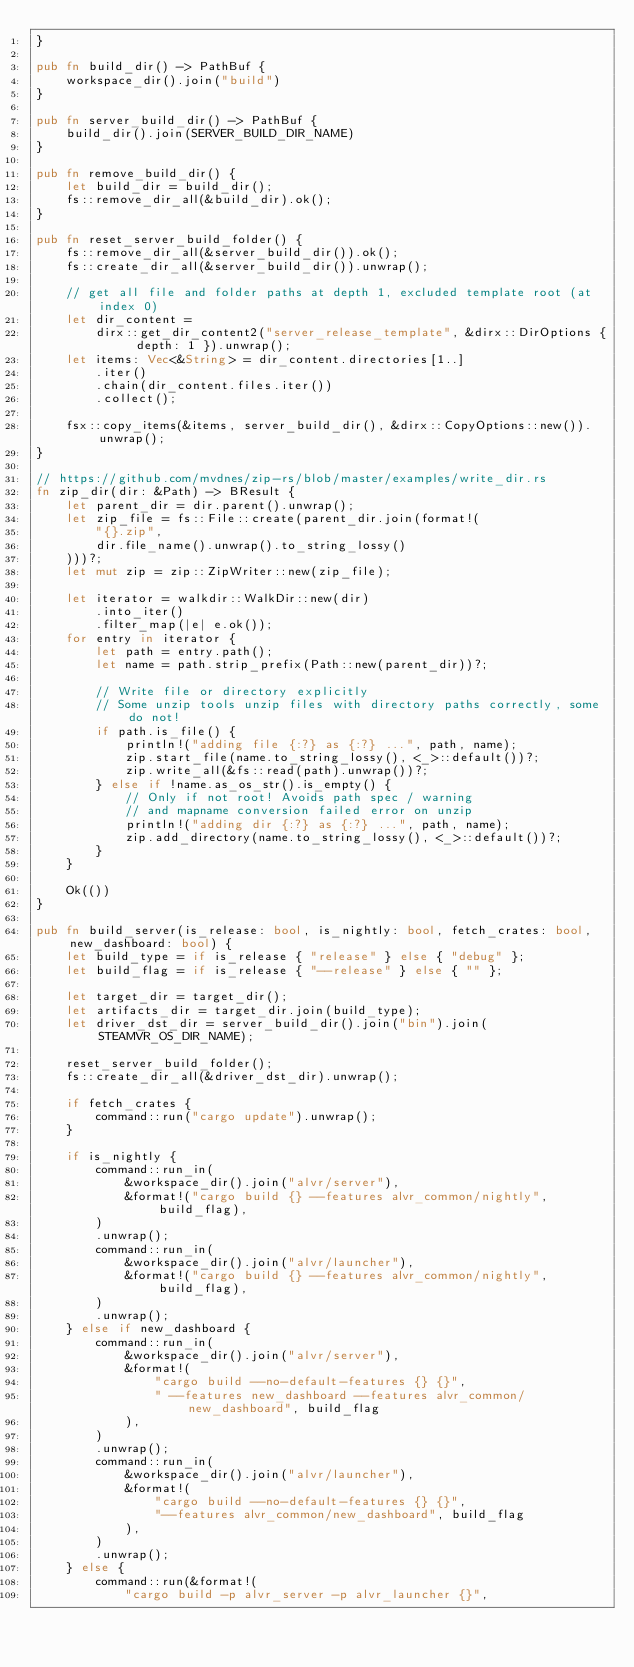<code> <loc_0><loc_0><loc_500><loc_500><_Rust_>}

pub fn build_dir() -> PathBuf {
    workspace_dir().join("build")
}

pub fn server_build_dir() -> PathBuf {
    build_dir().join(SERVER_BUILD_DIR_NAME)
}

pub fn remove_build_dir() {
    let build_dir = build_dir();
    fs::remove_dir_all(&build_dir).ok();
}

pub fn reset_server_build_folder() {
    fs::remove_dir_all(&server_build_dir()).ok();
    fs::create_dir_all(&server_build_dir()).unwrap();

    // get all file and folder paths at depth 1, excluded template root (at index 0)
    let dir_content =
        dirx::get_dir_content2("server_release_template", &dirx::DirOptions { depth: 1 }).unwrap();
    let items: Vec<&String> = dir_content.directories[1..]
        .iter()
        .chain(dir_content.files.iter())
        .collect();

    fsx::copy_items(&items, server_build_dir(), &dirx::CopyOptions::new()).unwrap();
}

// https://github.com/mvdnes/zip-rs/blob/master/examples/write_dir.rs
fn zip_dir(dir: &Path) -> BResult {
    let parent_dir = dir.parent().unwrap();
    let zip_file = fs::File::create(parent_dir.join(format!(
        "{}.zip",
        dir.file_name().unwrap().to_string_lossy()
    )))?;
    let mut zip = zip::ZipWriter::new(zip_file);

    let iterator = walkdir::WalkDir::new(dir)
        .into_iter()
        .filter_map(|e| e.ok());
    for entry in iterator {
        let path = entry.path();
        let name = path.strip_prefix(Path::new(parent_dir))?;

        // Write file or directory explicitly
        // Some unzip tools unzip files with directory paths correctly, some do not!
        if path.is_file() {
            println!("adding file {:?} as {:?} ...", path, name);
            zip.start_file(name.to_string_lossy(), <_>::default())?;
            zip.write_all(&fs::read(path).unwrap())?;
        } else if !name.as_os_str().is_empty() {
            // Only if not root! Avoids path spec / warning
            // and mapname conversion failed error on unzip
            println!("adding dir {:?} as {:?} ...", path, name);
            zip.add_directory(name.to_string_lossy(), <_>::default())?;
        }
    }

    Ok(())
}

pub fn build_server(is_release: bool, is_nightly: bool, fetch_crates: bool, new_dashboard: bool) {
    let build_type = if is_release { "release" } else { "debug" };
    let build_flag = if is_release { "--release" } else { "" };

    let target_dir = target_dir();
    let artifacts_dir = target_dir.join(build_type);
    let driver_dst_dir = server_build_dir().join("bin").join(STEAMVR_OS_DIR_NAME);

    reset_server_build_folder();
    fs::create_dir_all(&driver_dst_dir).unwrap();

    if fetch_crates {
        command::run("cargo update").unwrap();
    }

    if is_nightly {
        command::run_in(
            &workspace_dir().join("alvr/server"),
            &format!("cargo build {} --features alvr_common/nightly", build_flag),
        )
        .unwrap();
        command::run_in(
            &workspace_dir().join("alvr/launcher"),
            &format!("cargo build {} --features alvr_common/nightly", build_flag),
        )
        .unwrap();
    } else if new_dashboard {
        command::run_in(
            &workspace_dir().join("alvr/server"),
            &format!(
                "cargo build --no-default-features {} {}",
                " --features new_dashboard --features alvr_common/new_dashboard", build_flag
            ),
        )
        .unwrap();
        command::run_in(
            &workspace_dir().join("alvr/launcher"),
            &format!(
                "cargo build --no-default-features {} {}",
                "--features alvr_common/new_dashboard", build_flag
            ),
        )
        .unwrap();
    } else {
        command::run(&format!(
            "cargo build -p alvr_server -p alvr_launcher {}",</code> 